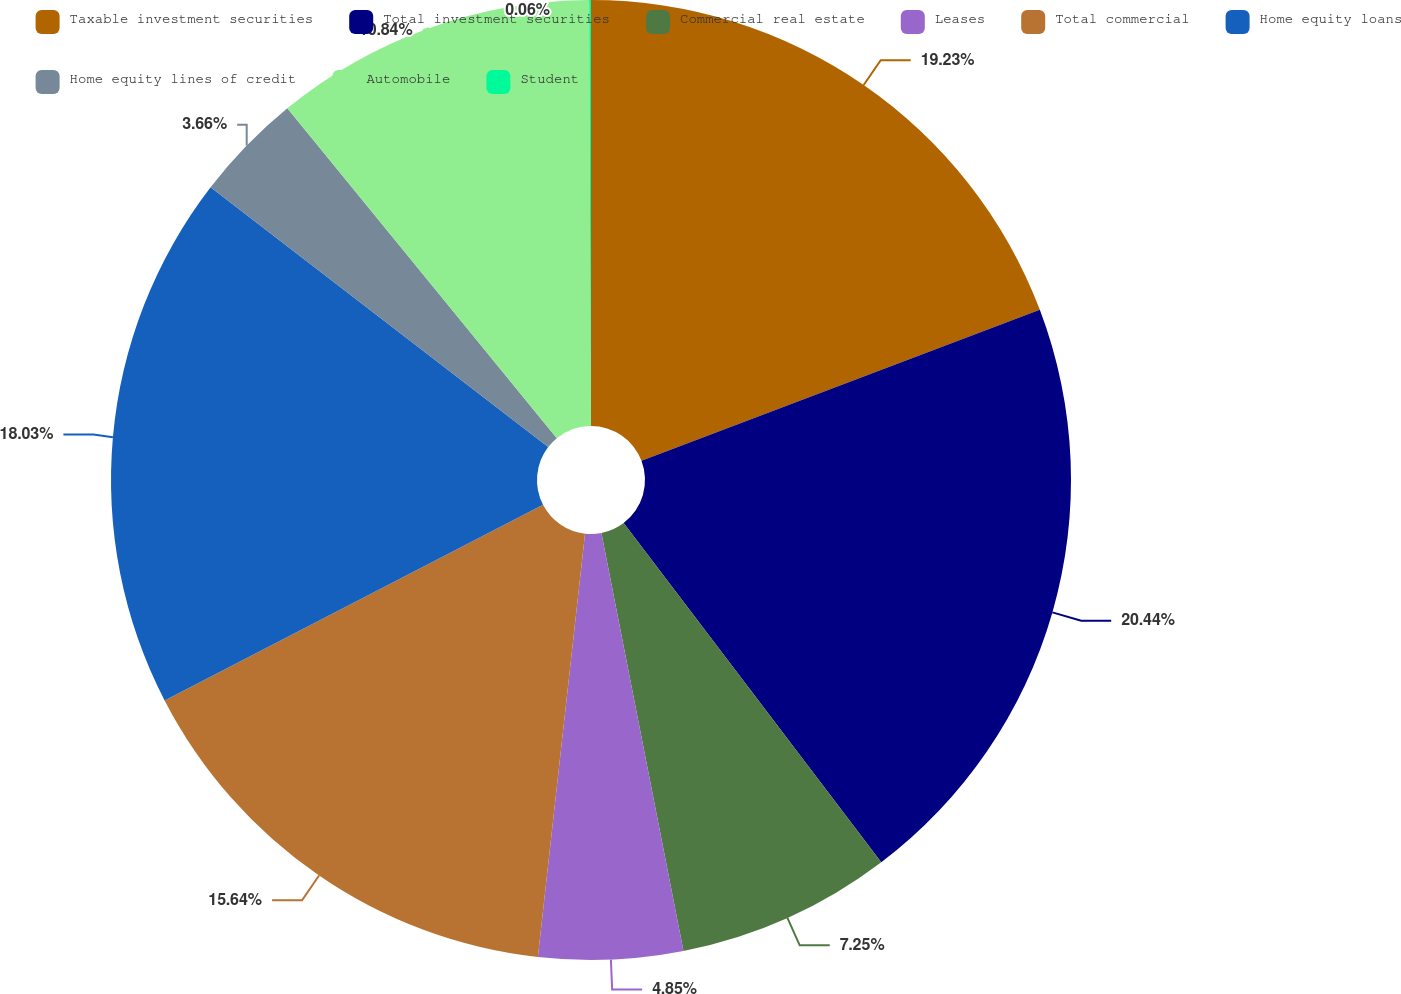<chart> <loc_0><loc_0><loc_500><loc_500><pie_chart><fcel>Taxable investment securities<fcel>Total investment securities<fcel>Commercial real estate<fcel>Leases<fcel>Total commercial<fcel>Home equity loans<fcel>Home equity lines of credit<fcel>Automobile<fcel>Student<nl><fcel>19.23%<fcel>20.43%<fcel>7.25%<fcel>4.85%<fcel>15.64%<fcel>18.03%<fcel>3.66%<fcel>10.84%<fcel>0.06%<nl></chart> 